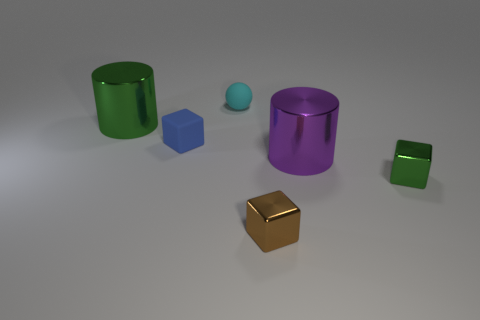Can you describe the size relationship among the objects? Certainly! There are two cylinders, one larger and one smaller. The larger cylinder is green and the smaller one is purple. There's also a large blue cube, a smaller green cube, and a small cyan sphere. At the foreground, there's a medium-sized gold cube that appears slightly taller than the green cube but not as tall as the cylinders. Could you estimate how the sizes of the cubes compare to the spheres? The blue cube and the gold cube are much larger in volume compared to the small cyan sphere. Cubes have six faces, edges, and vertices providing a clear contrast to the smooth, edgeless surface of the sphere. 